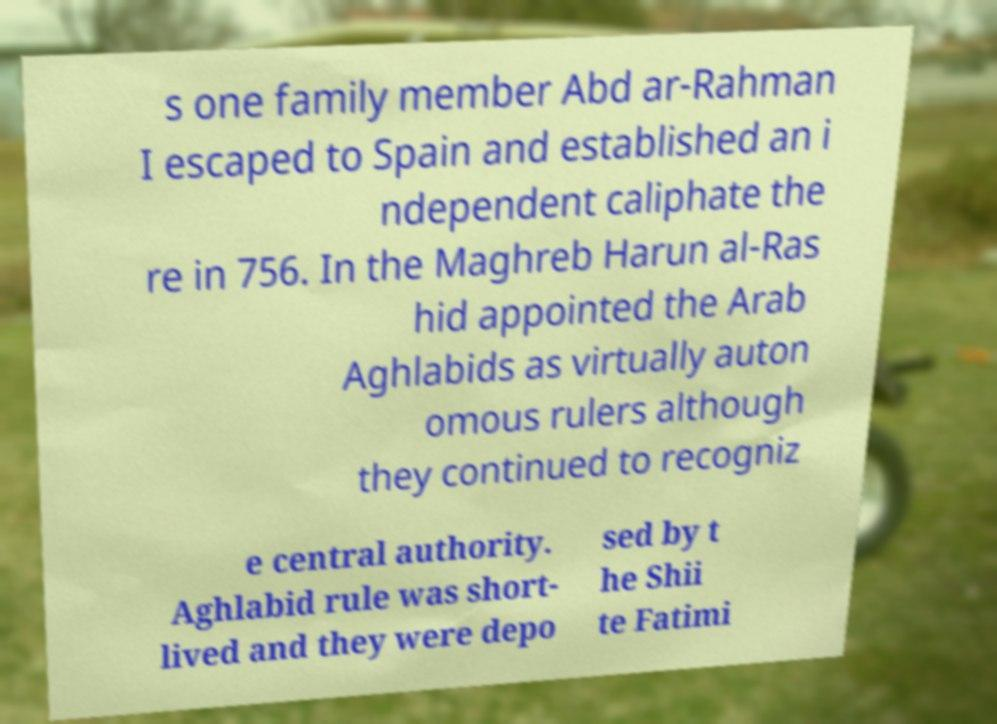Could you extract and type out the text from this image? s one family member Abd ar-Rahman I escaped to Spain and established an i ndependent caliphate the re in 756. In the Maghreb Harun al-Ras hid appointed the Arab Aghlabids as virtually auton omous rulers although they continued to recogniz e central authority. Aghlabid rule was short- lived and they were depo sed by t he Shii te Fatimi 